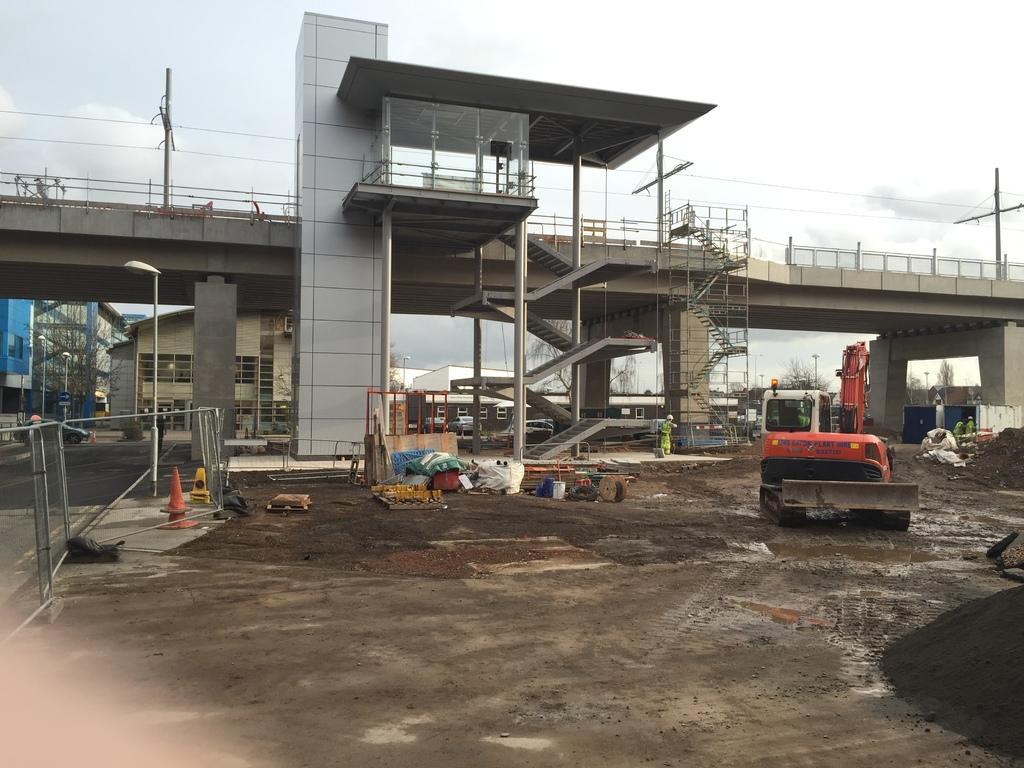Describe this image in one or two sentences. Completely an outdoor picture. Sky is cloudy. This is a bridge with steps. Pole is in white color. Far there are number of buildings with windows. Crane in red color. 